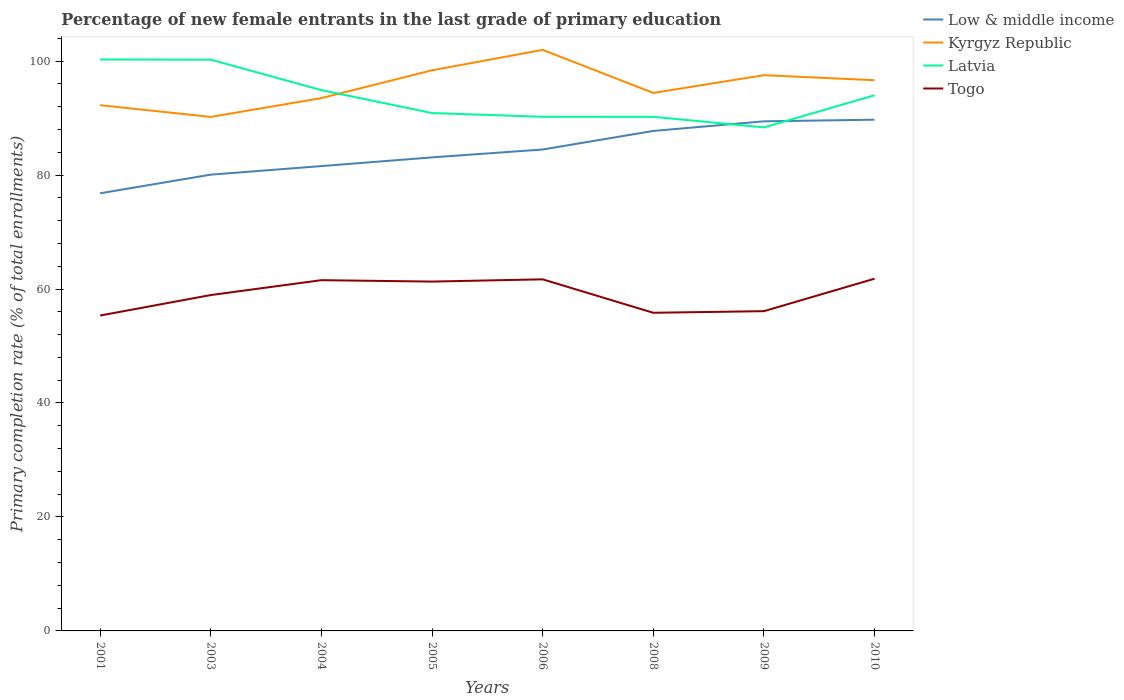Does the line corresponding to Kyrgyz Republic intersect with the line corresponding to Togo?
Keep it short and to the point. No. Across all years, what is the maximum percentage of new female entrants in Togo?
Your answer should be compact. 55.34. What is the total percentage of new female entrants in Togo in the graph?
Provide a short and direct response. -6.35. What is the difference between the highest and the second highest percentage of new female entrants in Togo?
Provide a short and direct response. 6.46. What is the difference between the highest and the lowest percentage of new female entrants in Kyrgyz Republic?
Give a very brief answer. 4. How many years are there in the graph?
Provide a short and direct response. 8. What is the difference between two consecutive major ticks on the Y-axis?
Provide a short and direct response. 20. Are the values on the major ticks of Y-axis written in scientific E-notation?
Ensure brevity in your answer.  No. Does the graph contain any zero values?
Provide a short and direct response. No. How are the legend labels stacked?
Make the answer very short. Vertical. What is the title of the graph?
Ensure brevity in your answer.  Percentage of new female entrants in the last grade of primary education. Does "Sudan" appear as one of the legend labels in the graph?
Your response must be concise. No. What is the label or title of the X-axis?
Provide a short and direct response. Years. What is the label or title of the Y-axis?
Ensure brevity in your answer.  Primary completion rate (% of total enrollments). What is the Primary completion rate (% of total enrollments) of Low & middle income in 2001?
Give a very brief answer. 76.79. What is the Primary completion rate (% of total enrollments) in Kyrgyz Republic in 2001?
Your answer should be very brief. 92.26. What is the Primary completion rate (% of total enrollments) of Latvia in 2001?
Give a very brief answer. 100.27. What is the Primary completion rate (% of total enrollments) of Togo in 2001?
Your answer should be very brief. 55.34. What is the Primary completion rate (% of total enrollments) of Low & middle income in 2003?
Keep it short and to the point. 80.07. What is the Primary completion rate (% of total enrollments) in Kyrgyz Republic in 2003?
Offer a terse response. 90.2. What is the Primary completion rate (% of total enrollments) of Latvia in 2003?
Make the answer very short. 100.25. What is the Primary completion rate (% of total enrollments) of Togo in 2003?
Make the answer very short. 58.94. What is the Primary completion rate (% of total enrollments) of Low & middle income in 2004?
Your answer should be very brief. 81.57. What is the Primary completion rate (% of total enrollments) of Kyrgyz Republic in 2004?
Give a very brief answer. 93.5. What is the Primary completion rate (% of total enrollments) of Latvia in 2004?
Offer a terse response. 94.9. What is the Primary completion rate (% of total enrollments) in Togo in 2004?
Your response must be concise. 61.55. What is the Primary completion rate (% of total enrollments) of Low & middle income in 2005?
Your response must be concise. 83.1. What is the Primary completion rate (% of total enrollments) in Kyrgyz Republic in 2005?
Your answer should be compact. 98.38. What is the Primary completion rate (% of total enrollments) of Latvia in 2005?
Provide a short and direct response. 90.88. What is the Primary completion rate (% of total enrollments) in Togo in 2005?
Offer a very short reply. 61.3. What is the Primary completion rate (% of total enrollments) in Low & middle income in 2006?
Your answer should be compact. 84.48. What is the Primary completion rate (% of total enrollments) in Kyrgyz Republic in 2006?
Make the answer very short. 101.97. What is the Primary completion rate (% of total enrollments) of Latvia in 2006?
Ensure brevity in your answer.  90.22. What is the Primary completion rate (% of total enrollments) of Togo in 2006?
Keep it short and to the point. 61.7. What is the Primary completion rate (% of total enrollments) of Low & middle income in 2008?
Keep it short and to the point. 87.74. What is the Primary completion rate (% of total enrollments) of Kyrgyz Republic in 2008?
Offer a terse response. 94.41. What is the Primary completion rate (% of total enrollments) of Latvia in 2008?
Your answer should be compact. 90.22. What is the Primary completion rate (% of total enrollments) of Togo in 2008?
Keep it short and to the point. 55.83. What is the Primary completion rate (% of total enrollments) in Low & middle income in 2009?
Your response must be concise. 89.42. What is the Primary completion rate (% of total enrollments) in Kyrgyz Republic in 2009?
Offer a very short reply. 97.52. What is the Primary completion rate (% of total enrollments) of Latvia in 2009?
Provide a succinct answer. 88.36. What is the Primary completion rate (% of total enrollments) of Togo in 2009?
Your response must be concise. 56.11. What is the Primary completion rate (% of total enrollments) in Low & middle income in 2010?
Your answer should be very brief. 89.71. What is the Primary completion rate (% of total enrollments) of Kyrgyz Republic in 2010?
Keep it short and to the point. 96.64. What is the Primary completion rate (% of total enrollments) of Latvia in 2010?
Offer a terse response. 94. What is the Primary completion rate (% of total enrollments) in Togo in 2010?
Your answer should be compact. 61.81. Across all years, what is the maximum Primary completion rate (% of total enrollments) of Low & middle income?
Offer a very short reply. 89.71. Across all years, what is the maximum Primary completion rate (% of total enrollments) of Kyrgyz Republic?
Keep it short and to the point. 101.97. Across all years, what is the maximum Primary completion rate (% of total enrollments) of Latvia?
Keep it short and to the point. 100.27. Across all years, what is the maximum Primary completion rate (% of total enrollments) in Togo?
Your answer should be compact. 61.81. Across all years, what is the minimum Primary completion rate (% of total enrollments) of Low & middle income?
Give a very brief answer. 76.79. Across all years, what is the minimum Primary completion rate (% of total enrollments) of Kyrgyz Republic?
Offer a very short reply. 90.2. Across all years, what is the minimum Primary completion rate (% of total enrollments) in Latvia?
Make the answer very short. 88.36. Across all years, what is the minimum Primary completion rate (% of total enrollments) of Togo?
Ensure brevity in your answer.  55.34. What is the total Primary completion rate (% of total enrollments) of Low & middle income in the graph?
Offer a very short reply. 672.87. What is the total Primary completion rate (% of total enrollments) of Kyrgyz Republic in the graph?
Offer a very short reply. 764.87. What is the total Primary completion rate (% of total enrollments) in Latvia in the graph?
Your answer should be compact. 749.09. What is the total Primary completion rate (% of total enrollments) in Togo in the graph?
Make the answer very short. 472.58. What is the difference between the Primary completion rate (% of total enrollments) in Low & middle income in 2001 and that in 2003?
Make the answer very short. -3.27. What is the difference between the Primary completion rate (% of total enrollments) in Kyrgyz Republic in 2001 and that in 2003?
Provide a short and direct response. 2.06. What is the difference between the Primary completion rate (% of total enrollments) in Latvia in 2001 and that in 2003?
Make the answer very short. 0.03. What is the difference between the Primary completion rate (% of total enrollments) in Togo in 2001 and that in 2003?
Make the answer very short. -3.59. What is the difference between the Primary completion rate (% of total enrollments) of Low & middle income in 2001 and that in 2004?
Keep it short and to the point. -4.77. What is the difference between the Primary completion rate (% of total enrollments) in Kyrgyz Republic in 2001 and that in 2004?
Provide a succinct answer. -1.24. What is the difference between the Primary completion rate (% of total enrollments) in Latvia in 2001 and that in 2004?
Make the answer very short. 5.37. What is the difference between the Primary completion rate (% of total enrollments) of Togo in 2001 and that in 2004?
Your response must be concise. -6.2. What is the difference between the Primary completion rate (% of total enrollments) of Low & middle income in 2001 and that in 2005?
Offer a terse response. -6.3. What is the difference between the Primary completion rate (% of total enrollments) of Kyrgyz Republic in 2001 and that in 2005?
Keep it short and to the point. -6.12. What is the difference between the Primary completion rate (% of total enrollments) in Latvia in 2001 and that in 2005?
Provide a short and direct response. 9.4. What is the difference between the Primary completion rate (% of total enrollments) of Togo in 2001 and that in 2005?
Your response must be concise. -5.96. What is the difference between the Primary completion rate (% of total enrollments) in Low & middle income in 2001 and that in 2006?
Provide a succinct answer. -7.69. What is the difference between the Primary completion rate (% of total enrollments) in Kyrgyz Republic in 2001 and that in 2006?
Provide a succinct answer. -9.7. What is the difference between the Primary completion rate (% of total enrollments) in Latvia in 2001 and that in 2006?
Keep it short and to the point. 10.05. What is the difference between the Primary completion rate (% of total enrollments) of Togo in 2001 and that in 2006?
Offer a very short reply. -6.35. What is the difference between the Primary completion rate (% of total enrollments) in Low & middle income in 2001 and that in 2008?
Provide a succinct answer. -10.94. What is the difference between the Primary completion rate (% of total enrollments) in Kyrgyz Republic in 2001 and that in 2008?
Provide a succinct answer. -2.15. What is the difference between the Primary completion rate (% of total enrollments) in Latvia in 2001 and that in 2008?
Your answer should be very brief. 10.06. What is the difference between the Primary completion rate (% of total enrollments) in Togo in 2001 and that in 2008?
Keep it short and to the point. -0.48. What is the difference between the Primary completion rate (% of total enrollments) in Low & middle income in 2001 and that in 2009?
Give a very brief answer. -12.63. What is the difference between the Primary completion rate (% of total enrollments) in Kyrgyz Republic in 2001 and that in 2009?
Your answer should be compact. -5.26. What is the difference between the Primary completion rate (% of total enrollments) of Latvia in 2001 and that in 2009?
Keep it short and to the point. 11.91. What is the difference between the Primary completion rate (% of total enrollments) of Togo in 2001 and that in 2009?
Give a very brief answer. -0.76. What is the difference between the Primary completion rate (% of total enrollments) of Low & middle income in 2001 and that in 2010?
Your response must be concise. -12.92. What is the difference between the Primary completion rate (% of total enrollments) of Kyrgyz Republic in 2001 and that in 2010?
Ensure brevity in your answer.  -4.38. What is the difference between the Primary completion rate (% of total enrollments) in Latvia in 2001 and that in 2010?
Your answer should be very brief. 6.27. What is the difference between the Primary completion rate (% of total enrollments) in Togo in 2001 and that in 2010?
Offer a very short reply. -6.46. What is the difference between the Primary completion rate (% of total enrollments) of Low & middle income in 2003 and that in 2004?
Offer a terse response. -1.5. What is the difference between the Primary completion rate (% of total enrollments) of Kyrgyz Republic in 2003 and that in 2004?
Ensure brevity in your answer.  -3.31. What is the difference between the Primary completion rate (% of total enrollments) of Latvia in 2003 and that in 2004?
Your answer should be very brief. 5.35. What is the difference between the Primary completion rate (% of total enrollments) in Togo in 2003 and that in 2004?
Offer a terse response. -2.61. What is the difference between the Primary completion rate (% of total enrollments) in Low & middle income in 2003 and that in 2005?
Ensure brevity in your answer.  -3.03. What is the difference between the Primary completion rate (% of total enrollments) of Kyrgyz Republic in 2003 and that in 2005?
Provide a succinct answer. -8.18. What is the difference between the Primary completion rate (% of total enrollments) of Latvia in 2003 and that in 2005?
Give a very brief answer. 9.37. What is the difference between the Primary completion rate (% of total enrollments) in Togo in 2003 and that in 2005?
Offer a very short reply. -2.36. What is the difference between the Primary completion rate (% of total enrollments) of Low & middle income in 2003 and that in 2006?
Ensure brevity in your answer.  -4.41. What is the difference between the Primary completion rate (% of total enrollments) in Kyrgyz Republic in 2003 and that in 2006?
Make the answer very short. -11.77. What is the difference between the Primary completion rate (% of total enrollments) of Latvia in 2003 and that in 2006?
Give a very brief answer. 10.02. What is the difference between the Primary completion rate (% of total enrollments) in Togo in 2003 and that in 2006?
Keep it short and to the point. -2.76. What is the difference between the Primary completion rate (% of total enrollments) of Low & middle income in 2003 and that in 2008?
Give a very brief answer. -7.67. What is the difference between the Primary completion rate (% of total enrollments) in Kyrgyz Republic in 2003 and that in 2008?
Offer a terse response. -4.21. What is the difference between the Primary completion rate (% of total enrollments) of Latvia in 2003 and that in 2008?
Ensure brevity in your answer.  10.03. What is the difference between the Primary completion rate (% of total enrollments) in Togo in 2003 and that in 2008?
Provide a short and direct response. 3.11. What is the difference between the Primary completion rate (% of total enrollments) of Low & middle income in 2003 and that in 2009?
Keep it short and to the point. -9.36. What is the difference between the Primary completion rate (% of total enrollments) in Kyrgyz Republic in 2003 and that in 2009?
Your response must be concise. -7.33. What is the difference between the Primary completion rate (% of total enrollments) in Latvia in 2003 and that in 2009?
Your response must be concise. 11.89. What is the difference between the Primary completion rate (% of total enrollments) in Togo in 2003 and that in 2009?
Provide a short and direct response. 2.83. What is the difference between the Primary completion rate (% of total enrollments) in Low & middle income in 2003 and that in 2010?
Your answer should be compact. -9.64. What is the difference between the Primary completion rate (% of total enrollments) in Kyrgyz Republic in 2003 and that in 2010?
Your answer should be very brief. -6.44. What is the difference between the Primary completion rate (% of total enrollments) in Latvia in 2003 and that in 2010?
Ensure brevity in your answer.  6.25. What is the difference between the Primary completion rate (% of total enrollments) of Togo in 2003 and that in 2010?
Ensure brevity in your answer.  -2.87. What is the difference between the Primary completion rate (% of total enrollments) in Low & middle income in 2004 and that in 2005?
Offer a terse response. -1.53. What is the difference between the Primary completion rate (% of total enrollments) in Kyrgyz Republic in 2004 and that in 2005?
Keep it short and to the point. -4.87. What is the difference between the Primary completion rate (% of total enrollments) of Latvia in 2004 and that in 2005?
Ensure brevity in your answer.  4.02. What is the difference between the Primary completion rate (% of total enrollments) in Togo in 2004 and that in 2005?
Offer a very short reply. 0.25. What is the difference between the Primary completion rate (% of total enrollments) of Low & middle income in 2004 and that in 2006?
Ensure brevity in your answer.  -2.91. What is the difference between the Primary completion rate (% of total enrollments) of Kyrgyz Republic in 2004 and that in 2006?
Give a very brief answer. -8.46. What is the difference between the Primary completion rate (% of total enrollments) of Latvia in 2004 and that in 2006?
Offer a terse response. 4.68. What is the difference between the Primary completion rate (% of total enrollments) in Togo in 2004 and that in 2006?
Make the answer very short. -0.15. What is the difference between the Primary completion rate (% of total enrollments) of Low & middle income in 2004 and that in 2008?
Your answer should be compact. -6.17. What is the difference between the Primary completion rate (% of total enrollments) in Kyrgyz Republic in 2004 and that in 2008?
Keep it short and to the point. -0.9. What is the difference between the Primary completion rate (% of total enrollments) in Latvia in 2004 and that in 2008?
Keep it short and to the point. 4.68. What is the difference between the Primary completion rate (% of total enrollments) of Togo in 2004 and that in 2008?
Your response must be concise. 5.72. What is the difference between the Primary completion rate (% of total enrollments) in Low & middle income in 2004 and that in 2009?
Provide a short and direct response. -7.86. What is the difference between the Primary completion rate (% of total enrollments) in Kyrgyz Republic in 2004 and that in 2009?
Give a very brief answer. -4.02. What is the difference between the Primary completion rate (% of total enrollments) in Latvia in 2004 and that in 2009?
Your answer should be very brief. 6.54. What is the difference between the Primary completion rate (% of total enrollments) in Togo in 2004 and that in 2009?
Provide a short and direct response. 5.44. What is the difference between the Primary completion rate (% of total enrollments) of Low & middle income in 2004 and that in 2010?
Ensure brevity in your answer.  -8.14. What is the difference between the Primary completion rate (% of total enrollments) in Kyrgyz Republic in 2004 and that in 2010?
Offer a very short reply. -3.13. What is the difference between the Primary completion rate (% of total enrollments) in Togo in 2004 and that in 2010?
Your response must be concise. -0.26. What is the difference between the Primary completion rate (% of total enrollments) in Low & middle income in 2005 and that in 2006?
Ensure brevity in your answer.  -1.38. What is the difference between the Primary completion rate (% of total enrollments) of Kyrgyz Republic in 2005 and that in 2006?
Give a very brief answer. -3.59. What is the difference between the Primary completion rate (% of total enrollments) in Latvia in 2005 and that in 2006?
Your response must be concise. 0.65. What is the difference between the Primary completion rate (% of total enrollments) of Togo in 2005 and that in 2006?
Your response must be concise. -0.39. What is the difference between the Primary completion rate (% of total enrollments) of Low & middle income in 2005 and that in 2008?
Your answer should be compact. -4.64. What is the difference between the Primary completion rate (% of total enrollments) in Kyrgyz Republic in 2005 and that in 2008?
Provide a short and direct response. 3.97. What is the difference between the Primary completion rate (% of total enrollments) of Latvia in 2005 and that in 2008?
Keep it short and to the point. 0.66. What is the difference between the Primary completion rate (% of total enrollments) in Togo in 2005 and that in 2008?
Keep it short and to the point. 5.47. What is the difference between the Primary completion rate (% of total enrollments) of Low & middle income in 2005 and that in 2009?
Offer a terse response. -6.33. What is the difference between the Primary completion rate (% of total enrollments) of Kyrgyz Republic in 2005 and that in 2009?
Your answer should be compact. 0.85. What is the difference between the Primary completion rate (% of total enrollments) of Latvia in 2005 and that in 2009?
Give a very brief answer. 2.52. What is the difference between the Primary completion rate (% of total enrollments) of Togo in 2005 and that in 2009?
Ensure brevity in your answer.  5.19. What is the difference between the Primary completion rate (% of total enrollments) in Low & middle income in 2005 and that in 2010?
Give a very brief answer. -6.61. What is the difference between the Primary completion rate (% of total enrollments) of Kyrgyz Republic in 2005 and that in 2010?
Your answer should be very brief. 1.74. What is the difference between the Primary completion rate (% of total enrollments) of Latvia in 2005 and that in 2010?
Offer a very short reply. -3.12. What is the difference between the Primary completion rate (% of total enrollments) of Togo in 2005 and that in 2010?
Offer a terse response. -0.51. What is the difference between the Primary completion rate (% of total enrollments) in Low & middle income in 2006 and that in 2008?
Keep it short and to the point. -3.26. What is the difference between the Primary completion rate (% of total enrollments) in Kyrgyz Republic in 2006 and that in 2008?
Give a very brief answer. 7.56. What is the difference between the Primary completion rate (% of total enrollments) of Latvia in 2006 and that in 2008?
Your answer should be compact. 0.01. What is the difference between the Primary completion rate (% of total enrollments) of Togo in 2006 and that in 2008?
Provide a succinct answer. 5.87. What is the difference between the Primary completion rate (% of total enrollments) in Low & middle income in 2006 and that in 2009?
Provide a succinct answer. -4.94. What is the difference between the Primary completion rate (% of total enrollments) of Kyrgyz Republic in 2006 and that in 2009?
Ensure brevity in your answer.  4.44. What is the difference between the Primary completion rate (% of total enrollments) in Latvia in 2006 and that in 2009?
Your answer should be very brief. 1.86. What is the difference between the Primary completion rate (% of total enrollments) in Togo in 2006 and that in 2009?
Offer a very short reply. 5.59. What is the difference between the Primary completion rate (% of total enrollments) of Low & middle income in 2006 and that in 2010?
Keep it short and to the point. -5.23. What is the difference between the Primary completion rate (% of total enrollments) of Kyrgyz Republic in 2006 and that in 2010?
Ensure brevity in your answer.  5.33. What is the difference between the Primary completion rate (% of total enrollments) in Latvia in 2006 and that in 2010?
Give a very brief answer. -3.78. What is the difference between the Primary completion rate (% of total enrollments) in Togo in 2006 and that in 2010?
Give a very brief answer. -0.11. What is the difference between the Primary completion rate (% of total enrollments) of Low & middle income in 2008 and that in 2009?
Provide a short and direct response. -1.69. What is the difference between the Primary completion rate (% of total enrollments) of Kyrgyz Republic in 2008 and that in 2009?
Give a very brief answer. -3.12. What is the difference between the Primary completion rate (% of total enrollments) of Latvia in 2008 and that in 2009?
Provide a short and direct response. 1.86. What is the difference between the Primary completion rate (% of total enrollments) of Togo in 2008 and that in 2009?
Ensure brevity in your answer.  -0.28. What is the difference between the Primary completion rate (% of total enrollments) in Low & middle income in 2008 and that in 2010?
Ensure brevity in your answer.  -1.97. What is the difference between the Primary completion rate (% of total enrollments) of Kyrgyz Republic in 2008 and that in 2010?
Give a very brief answer. -2.23. What is the difference between the Primary completion rate (% of total enrollments) of Latvia in 2008 and that in 2010?
Ensure brevity in your answer.  -3.78. What is the difference between the Primary completion rate (% of total enrollments) in Togo in 2008 and that in 2010?
Offer a very short reply. -5.98. What is the difference between the Primary completion rate (% of total enrollments) of Low & middle income in 2009 and that in 2010?
Provide a short and direct response. -0.29. What is the difference between the Primary completion rate (% of total enrollments) in Kyrgyz Republic in 2009 and that in 2010?
Make the answer very short. 0.89. What is the difference between the Primary completion rate (% of total enrollments) of Latvia in 2009 and that in 2010?
Give a very brief answer. -5.64. What is the difference between the Primary completion rate (% of total enrollments) of Togo in 2009 and that in 2010?
Your answer should be compact. -5.7. What is the difference between the Primary completion rate (% of total enrollments) in Low & middle income in 2001 and the Primary completion rate (% of total enrollments) in Kyrgyz Republic in 2003?
Offer a terse response. -13.4. What is the difference between the Primary completion rate (% of total enrollments) in Low & middle income in 2001 and the Primary completion rate (% of total enrollments) in Latvia in 2003?
Keep it short and to the point. -23.45. What is the difference between the Primary completion rate (% of total enrollments) of Low & middle income in 2001 and the Primary completion rate (% of total enrollments) of Togo in 2003?
Your answer should be compact. 17.85. What is the difference between the Primary completion rate (% of total enrollments) in Kyrgyz Republic in 2001 and the Primary completion rate (% of total enrollments) in Latvia in 2003?
Keep it short and to the point. -7.99. What is the difference between the Primary completion rate (% of total enrollments) in Kyrgyz Republic in 2001 and the Primary completion rate (% of total enrollments) in Togo in 2003?
Your response must be concise. 33.32. What is the difference between the Primary completion rate (% of total enrollments) in Latvia in 2001 and the Primary completion rate (% of total enrollments) in Togo in 2003?
Make the answer very short. 41.33. What is the difference between the Primary completion rate (% of total enrollments) in Low & middle income in 2001 and the Primary completion rate (% of total enrollments) in Kyrgyz Republic in 2004?
Ensure brevity in your answer.  -16.71. What is the difference between the Primary completion rate (% of total enrollments) in Low & middle income in 2001 and the Primary completion rate (% of total enrollments) in Latvia in 2004?
Offer a terse response. -18.11. What is the difference between the Primary completion rate (% of total enrollments) in Low & middle income in 2001 and the Primary completion rate (% of total enrollments) in Togo in 2004?
Your answer should be compact. 15.24. What is the difference between the Primary completion rate (% of total enrollments) of Kyrgyz Republic in 2001 and the Primary completion rate (% of total enrollments) of Latvia in 2004?
Ensure brevity in your answer.  -2.64. What is the difference between the Primary completion rate (% of total enrollments) in Kyrgyz Republic in 2001 and the Primary completion rate (% of total enrollments) in Togo in 2004?
Offer a very short reply. 30.71. What is the difference between the Primary completion rate (% of total enrollments) in Latvia in 2001 and the Primary completion rate (% of total enrollments) in Togo in 2004?
Offer a very short reply. 38.72. What is the difference between the Primary completion rate (% of total enrollments) in Low & middle income in 2001 and the Primary completion rate (% of total enrollments) in Kyrgyz Republic in 2005?
Provide a short and direct response. -21.58. What is the difference between the Primary completion rate (% of total enrollments) in Low & middle income in 2001 and the Primary completion rate (% of total enrollments) in Latvia in 2005?
Your answer should be very brief. -14.08. What is the difference between the Primary completion rate (% of total enrollments) in Low & middle income in 2001 and the Primary completion rate (% of total enrollments) in Togo in 2005?
Your answer should be very brief. 15.49. What is the difference between the Primary completion rate (% of total enrollments) of Kyrgyz Republic in 2001 and the Primary completion rate (% of total enrollments) of Latvia in 2005?
Ensure brevity in your answer.  1.38. What is the difference between the Primary completion rate (% of total enrollments) in Kyrgyz Republic in 2001 and the Primary completion rate (% of total enrollments) in Togo in 2005?
Keep it short and to the point. 30.96. What is the difference between the Primary completion rate (% of total enrollments) of Latvia in 2001 and the Primary completion rate (% of total enrollments) of Togo in 2005?
Give a very brief answer. 38.97. What is the difference between the Primary completion rate (% of total enrollments) of Low & middle income in 2001 and the Primary completion rate (% of total enrollments) of Kyrgyz Republic in 2006?
Provide a succinct answer. -25.17. What is the difference between the Primary completion rate (% of total enrollments) of Low & middle income in 2001 and the Primary completion rate (% of total enrollments) of Latvia in 2006?
Provide a succinct answer. -13.43. What is the difference between the Primary completion rate (% of total enrollments) in Low & middle income in 2001 and the Primary completion rate (% of total enrollments) in Togo in 2006?
Your answer should be very brief. 15.1. What is the difference between the Primary completion rate (% of total enrollments) of Kyrgyz Republic in 2001 and the Primary completion rate (% of total enrollments) of Latvia in 2006?
Your answer should be very brief. 2.04. What is the difference between the Primary completion rate (% of total enrollments) of Kyrgyz Republic in 2001 and the Primary completion rate (% of total enrollments) of Togo in 2006?
Your answer should be compact. 30.56. What is the difference between the Primary completion rate (% of total enrollments) in Latvia in 2001 and the Primary completion rate (% of total enrollments) in Togo in 2006?
Make the answer very short. 38.58. What is the difference between the Primary completion rate (% of total enrollments) in Low & middle income in 2001 and the Primary completion rate (% of total enrollments) in Kyrgyz Republic in 2008?
Offer a terse response. -17.61. What is the difference between the Primary completion rate (% of total enrollments) in Low & middle income in 2001 and the Primary completion rate (% of total enrollments) in Latvia in 2008?
Keep it short and to the point. -13.42. What is the difference between the Primary completion rate (% of total enrollments) in Low & middle income in 2001 and the Primary completion rate (% of total enrollments) in Togo in 2008?
Your answer should be very brief. 20.96. What is the difference between the Primary completion rate (% of total enrollments) of Kyrgyz Republic in 2001 and the Primary completion rate (% of total enrollments) of Latvia in 2008?
Keep it short and to the point. 2.04. What is the difference between the Primary completion rate (% of total enrollments) in Kyrgyz Republic in 2001 and the Primary completion rate (% of total enrollments) in Togo in 2008?
Offer a terse response. 36.43. What is the difference between the Primary completion rate (% of total enrollments) of Latvia in 2001 and the Primary completion rate (% of total enrollments) of Togo in 2008?
Offer a terse response. 44.44. What is the difference between the Primary completion rate (% of total enrollments) of Low & middle income in 2001 and the Primary completion rate (% of total enrollments) of Kyrgyz Republic in 2009?
Make the answer very short. -20.73. What is the difference between the Primary completion rate (% of total enrollments) of Low & middle income in 2001 and the Primary completion rate (% of total enrollments) of Latvia in 2009?
Offer a very short reply. -11.56. What is the difference between the Primary completion rate (% of total enrollments) of Low & middle income in 2001 and the Primary completion rate (% of total enrollments) of Togo in 2009?
Provide a short and direct response. 20.68. What is the difference between the Primary completion rate (% of total enrollments) in Kyrgyz Republic in 2001 and the Primary completion rate (% of total enrollments) in Latvia in 2009?
Provide a short and direct response. 3.9. What is the difference between the Primary completion rate (% of total enrollments) of Kyrgyz Republic in 2001 and the Primary completion rate (% of total enrollments) of Togo in 2009?
Provide a short and direct response. 36.15. What is the difference between the Primary completion rate (% of total enrollments) in Latvia in 2001 and the Primary completion rate (% of total enrollments) in Togo in 2009?
Provide a succinct answer. 44.16. What is the difference between the Primary completion rate (% of total enrollments) in Low & middle income in 2001 and the Primary completion rate (% of total enrollments) in Kyrgyz Republic in 2010?
Your answer should be compact. -19.84. What is the difference between the Primary completion rate (% of total enrollments) of Low & middle income in 2001 and the Primary completion rate (% of total enrollments) of Latvia in 2010?
Your answer should be very brief. -17.21. What is the difference between the Primary completion rate (% of total enrollments) in Low & middle income in 2001 and the Primary completion rate (% of total enrollments) in Togo in 2010?
Your answer should be very brief. 14.99. What is the difference between the Primary completion rate (% of total enrollments) of Kyrgyz Republic in 2001 and the Primary completion rate (% of total enrollments) of Latvia in 2010?
Keep it short and to the point. -1.74. What is the difference between the Primary completion rate (% of total enrollments) of Kyrgyz Republic in 2001 and the Primary completion rate (% of total enrollments) of Togo in 2010?
Provide a short and direct response. 30.45. What is the difference between the Primary completion rate (% of total enrollments) in Latvia in 2001 and the Primary completion rate (% of total enrollments) in Togo in 2010?
Ensure brevity in your answer.  38.47. What is the difference between the Primary completion rate (% of total enrollments) of Low & middle income in 2003 and the Primary completion rate (% of total enrollments) of Kyrgyz Republic in 2004?
Your answer should be very brief. -13.44. What is the difference between the Primary completion rate (% of total enrollments) of Low & middle income in 2003 and the Primary completion rate (% of total enrollments) of Latvia in 2004?
Provide a short and direct response. -14.83. What is the difference between the Primary completion rate (% of total enrollments) in Low & middle income in 2003 and the Primary completion rate (% of total enrollments) in Togo in 2004?
Offer a terse response. 18.52. What is the difference between the Primary completion rate (% of total enrollments) in Kyrgyz Republic in 2003 and the Primary completion rate (% of total enrollments) in Latvia in 2004?
Your answer should be very brief. -4.7. What is the difference between the Primary completion rate (% of total enrollments) in Kyrgyz Republic in 2003 and the Primary completion rate (% of total enrollments) in Togo in 2004?
Offer a very short reply. 28.65. What is the difference between the Primary completion rate (% of total enrollments) of Latvia in 2003 and the Primary completion rate (% of total enrollments) of Togo in 2004?
Ensure brevity in your answer.  38.7. What is the difference between the Primary completion rate (% of total enrollments) in Low & middle income in 2003 and the Primary completion rate (% of total enrollments) in Kyrgyz Republic in 2005?
Offer a very short reply. -18.31. What is the difference between the Primary completion rate (% of total enrollments) in Low & middle income in 2003 and the Primary completion rate (% of total enrollments) in Latvia in 2005?
Offer a terse response. -10.81. What is the difference between the Primary completion rate (% of total enrollments) of Low & middle income in 2003 and the Primary completion rate (% of total enrollments) of Togo in 2005?
Make the answer very short. 18.77. What is the difference between the Primary completion rate (% of total enrollments) in Kyrgyz Republic in 2003 and the Primary completion rate (% of total enrollments) in Latvia in 2005?
Provide a succinct answer. -0.68. What is the difference between the Primary completion rate (% of total enrollments) of Kyrgyz Republic in 2003 and the Primary completion rate (% of total enrollments) of Togo in 2005?
Your answer should be compact. 28.9. What is the difference between the Primary completion rate (% of total enrollments) in Latvia in 2003 and the Primary completion rate (% of total enrollments) in Togo in 2005?
Keep it short and to the point. 38.95. What is the difference between the Primary completion rate (% of total enrollments) in Low & middle income in 2003 and the Primary completion rate (% of total enrollments) in Kyrgyz Republic in 2006?
Provide a short and direct response. -21.9. What is the difference between the Primary completion rate (% of total enrollments) in Low & middle income in 2003 and the Primary completion rate (% of total enrollments) in Latvia in 2006?
Provide a short and direct response. -10.16. What is the difference between the Primary completion rate (% of total enrollments) in Low & middle income in 2003 and the Primary completion rate (% of total enrollments) in Togo in 2006?
Make the answer very short. 18.37. What is the difference between the Primary completion rate (% of total enrollments) of Kyrgyz Republic in 2003 and the Primary completion rate (% of total enrollments) of Latvia in 2006?
Your answer should be very brief. -0.03. What is the difference between the Primary completion rate (% of total enrollments) in Kyrgyz Republic in 2003 and the Primary completion rate (% of total enrollments) in Togo in 2006?
Offer a terse response. 28.5. What is the difference between the Primary completion rate (% of total enrollments) in Latvia in 2003 and the Primary completion rate (% of total enrollments) in Togo in 2006?
Your answer should be very brief. 38.55. What is the difference between the Primary completion rate (% of total enrollments) in Low & middle income in 2003 and the Primary completion rate (% of total enrollments) in Kyrgyz Republic in 2008?
Offer a very short reply. -14.34. What is the difference between the Primary completion rate (% of total enrollments) in Low & middle income in 2003 and the Primary completion rate (% of total enrollments) in Latvia in 2008?
Keep it short and to the point. -10.15. What is the difference between the Primary completion rate (% of total enrollments) of Low & middle income in 2003 and the Primary completion rate (% of total enrollments) of Togo in 2008?
Provide a short and direct response. 24.24. What is the difference between the Primary completion rate (% of total enrollments) of Kyrgyz Republic in 2003 and the Primary completion rate (% of total enrollments) of Latvia in 2008?
Provide a succinct answer. -0.02. What is the difference between the Primary completion rate (% of total enrollments) of Kyrgyz Republic in 2003 and the Primary completion rate (% of total enrollments) of Togo in 2008?
Make the answer very short. 34.37. What is the difference between the Primary completion rate (% of total enrollments) in Latvia in 2003 and the Primary completion rate (% of total enrollments) in Togo in 2008?
Provide a short and direct response. 44.42. What is the difference between the Primary completion rate (% of total enrollments) in Low & middle income in 2003 and the Primary completion rate (% of total enrollments) in Kyrgyz Republic in 2009?
Make the answer very short. -17.46. What is the difference between the Primary completion rate (% of total enrollments) in Low & middle income in 2003 and the Primary completion rate (% of total enrollments) in Latvia in 2009?
Provide a short and direct response. -8.29. What is the difference between the Primary completion rate (% of total enrollments) in Low & middle income in 2003 and the Primary completion rate (% of total enrollments) in Togo in 2009?
Offer a terse response. 23.96. What is the difference between the Primary completion rate (% of total enrollments) of Kyrgyz Republic in 2003 and the Primary completion rate (% of total enrollments) of Latvia in 2009?
Your response must be concise. 1.84. What is the difference between the Primary completion rate (% of total enrollments) of Kyrgyz Republic in 2003 and the Primary completion rate (% of total enrollments) of Togo in 2009?
Give a very brief answer. 34.09. What is the difference between the Primary completion rate (% of total enrollments) of Latvia in 2003 and the Primary completion rate (% of total enrollments) of Togo in 2009?
Your response must be concise. 44.14. What is the difference between the Primary completion rate (% of total enrollments) in Low & middle income in 2003 and the Primary completion rate (% of total enrollments) in Kyrgyz Republic in 2010?
Your answer should be very brief. -16.57. What is the difference between the Primary completion rate (% of total enrollments) of Low & middle income in 2003 and the Primary completion rate (% of total enrollments) of Latvia in 2010?
Provide a short and direct response. -13.93. What is the difference between the Primary completion rate (% of total enrollments) in Low & middle income in 2003 and the Primary completion rate (% of total enrollments) in Togo in 2010?
Your answer should be compact. 18.26. What is the difference between the Primary completion rate (% of total enrollments) of Kyrgyz Republic in 2003 and the Primary completion rate (% of total enrollments) of Latvia in 2010?
Your answer should be compact. -3.8. What is the difference between the Primary completion rate (% of total enrollments) in Kyrgyz Republic in 2003 and the Primary completion rate (% of total enrollments) in Togo in 2010?
Your answer should be very brief. 28.39. What is the difference between the Primary completion rate (% of total enrollments) of Latvia in 2003 and the Primary completion rate (% of total enrollments) of Togo in 2010?
Your response must be concise. 38.44. What is the difference between the Primary completion rate (% of total enrollments) of Low & middle income in 2004 and the Primary completion rate (% of total enrollments) of Kyrgyz Republic in 2005?
Your answer should be compact. -16.81. What is the difference between the Primary completion rate (% of total enrollments) of Low & middle income in 2004 and the Primary completion rate (% of total enrollments) of Latvia in 2005?
Offer a terse response. -9.31. What is the difference between the Primary completion rate (% of total enrollments) in Low & middle income in 2004 and the Primary completion rate (% of total enrollments) in Togo in 2005?
Your response must be concise. 20.27. What is the difference between the Primary completion rate (% of total enrollments) in Kyrgyz Republic in 2004 and the Primary completion rate (% of total enrollments) in Latvia in 2005?
Provide a succinct answer. 2.63. What is the difference between the Primary completion rate (% of total enrollments) in Kyrgyz Republic in 2004 and the Primary completion rate (% of total enrollments) in Togo in 2005?
Ensure brevity in your answer.  32.2. What is the difference between the Primary completion rate (% of total enrollments) in Latvia in 2004 and the Primary completion rate (% of total enrollments) in Togo in 2005?
Your response must be concise. 33.6. What is the difference between the Primary completion rate (% of total enrollments) of Low & middle income in 2004 and the Primary completion rate (% of total enrollments) of Kyrgyz Republic in 2006?
Offer a terse response. -20.4. What is the difference between the Primary completion rate (% of total enrollments) in Low & middle income in 2004 and the Primary completion rate (% of total enrollments) in Latvia in 2006?
Keep it short and to the point. -8.66. What is the difference between the Primary completion rate (% of total enrollments) of Low & middle income in 2004 and the Primary completion rate (% of total enrollments) of Togo in 2006?
Your answer should be compact. 19.87. What is the difference between the Primary completion rate (% of total enrollments) of Kyrgyz Republic in 2004 and the Primary completion rate (% of total enrollments) of Latvia in 2006?
Keep it short and to the point. 3.28. What is the difference between the Primary completion rate (% of total enrollments) of Kyrgyz Republic in 2004 and the Primary completion rate (% of total enrollments) of Togo in 2006?
Give a very brief answer. 31.81. What is the difference between the Primary completion rate (% of total enrollments) in Latvia in 2004 and the Primary completion rate (% of total enrollments) in Togo in 2006?
Provide a short and direct response. 33.2. What is the difference between the Primary completion rate (% of total enrollments) of Low & middle income in 2004 and the Primary completion rate (% of total enrollments) of Kyrgyz Republic in 2008?
Offer a very short reply. -12.84. What is the difference between the Primary completion rate (% of total enrollments) of Low & middle income in 2004 and the Primary completion rate (% of total enrollments) of Latvia in 2008?
Offer a very short reply. -8.65. What is the difference between the Primary completion rate (% of total enrollments) of Low & middle income in 2004 and the Primary completion rate (% of total enrollments) of Togo in 2008?
Ensure brevity in your answer.  25.74. What is the difference between the Primary completion rate (% of total enrollments) in Kyrgyz Republic in 2004 and the Primary completion rate (% of total enrollments) in Latvia in 2008?
Ensure brevity in your answer.  3.29. What is the difference between the Primary completion rate (% of total enrollments) of Kyrgyz Republic in 2004 and the Primary completion rate (% of total enrollments) of Togo in 2008?
Your answer should be very brief. 37.67. What is the difference between the Primary completion rate (% of total enrollments) in Latvia in 2004 and the Primary completion rate (% of total enrollments) in Togo in 2008?
Provide a short and direct response. 39.07. What is the difference between the Primary completion rate (% of total enrollments) in Low & middle income in 2004 and the Primary completion rate (% of total enrollments) in Kyrgyz Republic in 2009?
Offer a very short reply. -15.96. What is the difference between the Primary completion rate (% of total enrollments) in Low & middle income in 2004 and the Primary completion rate (% of total enrollments) in Latvia in 2009?
Provide a short and direct response. -6.79. What is the difference between the Primary completion rate (% of total enrollments) in Low & middle income in 2004 and the Primary completion rate (% of total enrollments) in Togo in 2009?
Your answer should be very brief. 25.46. What is the difference between the Primary completion rate (% of total enrollments) in Kyrgyz Republic in 2004 and the Primary completion rate (% of total enrollments) in Latvia in 2009?
Keep it short and to the point. 5.14. What is the difference between the Primary completion rate (% of total enrollments) in Kyrgyz Republic in 2004 and the Primary completion rate (% of total enrollments) in Togo in 2009?
Provide a succinct answer. 37.39. What is the difference between the Primary completion rate (% of total enrollments) of Latvia in 2004 and the Primary completion rate (% of total enrollments) of Togo in 2009?
Offer a very short reply. 38.79. What is the difference between the Primary completion rate (% of total enrollments) of Low & middle income in 2004 and the Primary completion rate (% of total enrollments) of Kyrgyz Republic in 2010?
Ensure brevity in your answer.  -15.07. What is the difference between the Primary completion rate (% of total enrollments) in Low & middle income in 2004 and the Primary completion rate (% of total enrollments) in Latvia in 2010?
Ensure brevity in your answer.  -12.43. What is the difference between the Primary completion rate (% of total enrollments) in Low & middle income in 2004 and the Primary completion rate (% of total enrollments) in Togo in 2010?
Make the answer very short. 19.76. What is the difference between the Primary completion rate (% of total enrollments) of Kyrgyz Republic in 2004 and the Primary completion rate (% of total enrollments) of Latvia in 2010?
Your response must be concise. -0.5. What is the difference between the Primary completion rate (% of total enrollments) of Kyrgyz Republic in 2004 and the Primary completion rate (% of total enrollments) of Togo in 2010?
Ensure brevity in your answer.  31.7. What is the difference between the Primary completion rate (% of total enrollments) in Latvia in 2004 and the Primary completion rate (% of total enrollments) in Togo in 2010?
Provide a succinct answer. 33.09. What is the difference between the Primary completion rate (% of total enrollments) of Low & middle income in 2005 and the Primary completion rate (% of total enrollments) of Kyrgyz Republic in 2006?
Your answer should be compact. -18.87. What is the difference between the Primary completion rate (% of total enrollments) of Low & middle income in 2005 and the Primary completion rate (% of total enrollments) of Latvia in 2006?
Your answer should be very brief. -7.12. What is the difference between the Primary completion rate (% of total enrollments) in Low & middle income in 2005 and the Primary completion rate (% of total enrollments) in Togo in 2006?
Your answer should be compact. 21.4. What is the difference between the Primary completion rate (% of total enrollments) in Kyrgyz Republic in 2005 and the Primary completion rate (% of total enrollments) in Latvia in 2006?
Provide a succinct answer. 8.15. What is the difference between the Primary completion rate (% of total enrollments) of Kyrgyz Republic in 2005 and the Primary completion rate (% of total enrollments) of Togo in 2006?
Provide a succinct answer. 36.68. What is the difference between the Primary completion rate (% of total enrollments) of Latvia in 2005 and the Primary completion rate (% of total enrollments) of Togo in 2006?
Give a very brief answer. 29.18. What is the difference between the Primary completion rate (% of total enrollments) in Low & middle income in 2005 and the Primary completion rate (% of total enrollments) in Kyrgyz Republic in 2008?
Provide a short and direct response. -11.31. What is the difference between the Primary completion rate (% of total enrollments) of Low & middle income in 2005 and the Primary completion rate (% of total enrollments) of Latvia in 2008?
Your answer should be very brief. -7.12. What is the difference between the Primary completion rate (% of total enrollments) of Low & middle income in 2005 and the Primary completion rate (% of total enrollments) of Togo in 2008?
Keep it short and to the point. 27.27. What is the difference between the Primary completion rate (% of total enrollments) of Kyrgyz Republic in 2005 and the Primary completion rate (% of total enrollments) of Latvia in 2008?
Make the answer very short. 8.16. What is the difference between the Primary completion rate (% of total enrollments) of Kyrgyz Republic in 2005 and the Primary completion rate (% of total enrollments) of Togo in 2008?
Provide a short and direct response. 42.55. What is the difference between the Primary completion rate (% of total enrollments) in Latvia in 2005 and the Primary completion rate (% of total enrollments) in Togo in 2008?
Give a very brief answer. 35.05. What is the difference between the Primary completion rate (% of total enrollments) in Low & middle income in 2005 and the Primary completion rate (% of total enrollments) in Kyrgyz Republic in 2009?
Give a very brief answer. -14.42. What is the difference between the Primary completion rate (% of total enrollments) in Low & middle income in 2005 and the Primary completion rate (% of total enrollments) in Latvia in 2009?
Make the answer very short. -5.26. What is the difference between the Primary completion rate (% of total enrollments) in Low & middle income in 2005 and the Primary completion rate (% of total enrollments) in Togo in 2009?
Your response must be concise. 26.99. What is the difference between the Primary completion rate (% of total enrollments) in Kyrgyz Republic in 2005 and the Primary completion rate (% of total enrollments) in Latvia in 2009?
Your response must be concise. 10.02. What is the difference between the Primary completion rate (% of total enrollments) in Kyrgyz Republic in 2005 and the Primary completion rate (% of total enrollments) in Togo in 2009?
Keep it short and to the point. 42.27. What is the difference between the Primary completion rate (% of total enrollments) of Latvia in 2005 and the Primary completion rate (% of total enrollments) of Togo in 2009?
Your answer should be compact. 34.77. What is the difference between the Primary completion rate (% of total enrollments) of Low & middle income in 2005 and the Primary completion rate (% of total enrollments) of Kyrgyz Republic in 2010?
Your answer should be very brief. -13.54. What is the difference between the Primary completion rate (% of total enrollments) in Low & middle income in 2005 and the Primary completion rate (% of total enrollments) in Latvia in 2010?
Provide a short and direct response. -10.9. What is the difference between the Primary completion rate (% of total enrollments) in Low & middle income in 2005 and the Primary completion rate (% of total enrollments) in Togo in 2010?
Ensure brevity in your answer.  21.29. What is the difference between the Primary completion rate (% of total enrollments) in Kyrgyz Republic in 2005 and the Primary completion rate (% of total enrollments) in Latvia in 2010?
Your response must be concise. 4.38. What is the difference between the Primary completion rate (% of total enrollments) in Kyrgyz Republic in 2005 and the Primary completion rate (% of total enrollments) in Togo in 2010?
Offer a very short reply. 36.57. What is the difference between the Primary completion rate (% of total enrollments) in Latvia in 2005 and the Primary completion rate (% of total enrollments) in Togo in 2010?
Provide a succinct answer. 29.07. What is the difference between the Primary completion rate (% of total enrollments) of Low & middle income in 2006 and the Primary completion rate (% of total enrollments) of Kyrgyz Republic in 2008?
Offer a very short reply. -9.93. What is the difference between the Primary completion rate (% of total enrollments) in Low & middle income in 2006 and the Primary completion rate (% of total enrollments) in Latvia in 2008?
Ensure brevity in your answer.  -5.74. What is the difference between the Primary completion rate (% of total enrollments) in Low & middle income in 2006 and the Primary completion rate (% of total enrollments) in Togo in 2008?
Provide a short and direct response. 28.65. What is the difference between the Primary completion rate (% of total enrollments) in Kyrgyz Republic in 2006 and the Primary completion rate (% of total enrollments) in Latvia in 2008?
Give a very brief answer. 11.75. What is the difference between the Primary completion rate (% of total enrollments) of Kyrgyz Republic in 2006 and the Primary completion rate (% of total enrollments) of Togo in 2008?
Provide a short and direct response. 46.14. What is the difference between the Primary completion rate (% of total enrollments) of Latvia in 2006 and the Primary completion rate (% of total enrollments) of Togo in 2008?
Keep it short and to the point. 34.39. What is the difference between the Primary completion rate (% of total enrollments) of Low & middle income in 2006 and the Primary completion rate (% of total enrollments) of Kyrgyz Republic in 2009?
Provide a succinct answer. -13.04. What is the difference between the Primary completion rate (% of total enrollments) in Low & middle income in 2006 and the Primary completion rate (% of total enrollments) in Latvia in 2009?
Make the answer very short. -3.88. What is the difference between the Primary completion rate (% of total enrollments) in Low & middle income in 2006 and the Primary completion rate (% of total enrollments) in Togo in 2009?
Ensure brevity in your answer.  28.37. What is the difference between the Primary completion rate (% of total enrollments) of Kyrgyz Republic in 2006 and the Primary completion rate (% of total enrollments) of Latvia in 2009?
Offer a terse response. 13.61. What is the difference between the Primary completion rate (% of total enrollments) of Kyrgyz Republic in 2006 and the Primary completion rate (% of total enrollments) of Togo in 2009?
Offer a terse response. 45.86. What is the difference between the Primary completion rate (% of total enrollments) of Latvia in 2006 and the Primary completion rate (% of total enrollments) of Togo in 2009?
Your response must be concise. 34.11. What is the difference between the Primary completion rate (% of total enrollments) in Low & middle income in 2006 and the Primary completion rate (% of total enrollments) in Kyrgyz Republic in 2010?
Your answer should be compact. -12.16. What is the difference between the Primary completion rate (% of total enrollments) of Low & middle income in 2006 and the Primary completion rate (% of total enrollments) of Latvia in 2010?
Keep it short and to the point. -9.52. What is the difference between the Primary completion rate (% of total enrollments) of Low & middle income in 2006 and the Primary completion rate (% of total enrollments) of Togo in 2010?
Provide a succinct answer. 22.67. What is the difference between the Primary completion rate (% of total enrollments) of Kyrgyz Republic in 2006 and the Primary completion rate (% of total enrollments) of Latvia in 2010?
Offer a very short reply. 7.97. What is the difference between the Primary completion rate (% of total enrollments) of Kyrgyz Republic in 2006 and the Primary completion rate (% of total enrollments) of Togo in 2010?
Your answer should be compact. 40.16. What is the difference between the Primary completion rate (% of total enrollments) in Latvia in 2006 and the Primary completion rate (% of total enrollments) in Togo in 2010?
Provide a short and direct response. 28.42. What is the difference between the Primary completion rate (% of total enrollments) in Low & middle income in 2008 and the Primary completion rate (% of total enrollments) in Kyrgyz Republic in 2009?
Ensure brevity in your answer.  -9.79. What is the difference between the Primary completion rate (% of total enrollments) of Low & middle income in 2008 and the Primary completion rate (% of total enrollments) of Latvia in 2009?
Your answer should be compact. -0.62. What is the difference between the Primary completion rate (% of total enrollments) in Low & middle income in 2008 and the Primary completion rate (% of total enrollments) in Togo in 2009?
Your answer should be compact. 31.63. What is the difference between the Primary completion rate (% of total enrollments) in Kyrgyz Republic in 2008 and the Primary completion rate (% of total enrollments) in Latvia in 2009?
Give a very brief answer. 6.05. What is the difference between the Primary completion rate (% of total enrollments) in Kyrgyz Republic in 2008 and the Primary completion rate (% of total enrollments) in Togo in 2009?
Your response must be concise. 38.3. What is the difference between the Primary completion rate (% of total enrollments) in Latvia in 2008 and the Primary completion rate (% of total enrollments) in Togo in 2009?
Provide a short and direct response. 34.11. What is the difference between the Primary completion rate (% of total enrollments) in Low & middle income in 2008 and the Primary completion rate (% of total enrollments) in Kyrgyz Republic in 2010?
Make the answer very short. -8.9. What is the difference between the Primary completion rate (% of total enrollments) of Low & middle income in 2008 and the Primary completion rate (% of total enrollments) of Latvia in 2010?
Offer a very short reply. -6.26. What is the difference between the Primary completion rate (% of total enrollments) of Low & middle income in 2008 and the Primary completion rate (% of total enrollments) of Togo in 2010?
Your response must be concise. 25.93. What is the difference between the Primary completion rate (% of total enrollments) of Kyrgyz Republic in 2008 and the Primary completion rate (% of total enrollments) of Latvia in 2010?
Your response must be concise. 0.41. What is the difference between the Primary completion rate (% of total enrollments) in Kyrgyz Republic in 2008 and the Primary completion rate (% of total enrollments) in Togo in 2010?
Provide a short and direct response. 32.6. What is the difference between the Primary completion rate (% of total enrollments) in Latvia in 2008 and the Primary completion rate (% of total enrollments) in Togo in 2010?
Ensure brevity in your answer.  28.41. What is the difference between the Primary completion rate (% of total enrollments) of Low & middle income in 2009 and the Primary completion rate (% of total enrollments) of Kyrgyz Republic in 2010?
Give a very brief answer. -7.21. What is the difference between the Primary completion rate (% of total enrollments) of Low & middle income in 2009 and the Primary completion rate (% of total enrollments) of Latvia in 2010?
Make the answer very short. -4.57. What is the difference between the Primary completion rate (% of total enrollments) of Low & middle income in 2009 and the Primary completion rate (% of total enrollments) of Togo in 2010?
Your answer should be very brief. 27.62. What is the difference between the Primary completion rate (% of total enrollments) in Kyrgyz Republic in 2009 and the Primary completion rate (% of total enrollments) in Latvia in 2010?
Your answer should be compact. 3.52. What is the difference between the Primary completion rate (% of total enrollments) of Kyrgyz Republic in 2009 and the Primary completion rate (% of total enrollments) of Togo in 2010?
Your answer should be very brief. 35.72. What is the difference between the Primary completion rate (% of total enrollments) in Latvia in 2009 and the Primary completion rate (% of total enrollments) in Togo in 2010?
Provide a short and direct response. 26.55. What is the average Primary completion rate (% of total enrollments) in Low & middle income per year?
Offer a very short reply. 84.11. What is the average Primary completion rate (% of total enrollments) in Kyrgyz Republic per year?
Offer a terse response. 95.61. What is the average Primary completion rate (% of total enrollments) in Latvia per year?
Provide a succinct answer. 93.64. What is the average Primary completion rate (% of total enrollments) in Togo per year?
Provide a short and direct response. 59.07. In the year 2001, what is the difference between the Primary completion rate (% of total enrollments) of Low & middle income and Primary completion rate (% of total enrollments) of Kyrgyz Republic?
Your answer should be very brief. -15.47. In the year 2001, what is the difference between the Primary completion rate (% of total enrollments) of Low & middle income and Primary completion rate (% of total enrollments) of Latvia?
Provide a short and direct response. -23.48. In the year 2001, what is the difference between the Primary completion rate (% of total enrollments) of Low & middle income and Primary completion rate (% of total enrollments) of Togo?
Keep it short and to the point. 21.45. In the year 2001, what is the difference between the Primary completion rate (% of total enrollments) of Kyrgyz Republic and Primary completion rate (% of total enrollments) of Latvia?
Make the answer very short. -8.01. In the year 2001, what is the difference between the Primary completion rate (% of total enrollments) in Kyrgyz Republic and Primary completion rate (% of total enrollments) in Togo?
Your answer should be very brief. 36.92. In the year 2001, what is the difference between the Primary completion rate (% of total enrollments) of Latvia and Primary completion rate (% of total enrollments) of Togo?
Provide a short and direct response. 44.93. In the year 2003, what is the difference between the Primary completion rate (% of total enrollments) in Low & middle income and Primary completion rate (% of total enrollments) in Kyrgyz Republic?
Keep it short and to the point. -10.13. In the year 2003, what is the difference between the Primary completion rate (% of total enrollments) in Low & middle income and Primary completion rate (% of total enrollments) in Latvia?
Your response must be concise. -20.18. In the year 2003, what is the difference between the Primary completion rate (% of total enrollments) in Low & middle income and Primary completion rate (% of total enrollments) in Togo?
Provide a short and direct response. 21.13. In the year 2003, what is the difference between the Primary completion rate (% of total enrollments) of Kyrgyz Republic and Primary completion rate (% of total enrollments) of Latvia?
Your answer should be very brief. -10.05. In the year 2003, what is the difference between the Primary completion rate (% of total enrollments) in Kyrgyz Republic and Primary completion rate (% of total enrollments) in Togo?
Offer a very short reply. 31.26. In the year 2003, what is the difference between the Primary completion rate (% of total enrollments) of Latvia and Primary completion rate (% of total enrollments) of Togo?
Offer a very short reply. 41.31. In the year 2004, what is the difference between the Primary completion rate (% of total enrollments) in Low & middle income and Primary completion rate (% of total enrollments) in Kyrgyz Republic?
Your response must be concise. -11.94. In the year 2004, what is the difference between the Primary completion rate (% of total enrollments) in Low & middle income and Primary completion rate (% of total enrollments) in Latvia?
Offer a very short reply. -13.33. In the year 2004, what is the difference between the Primary completion rate (% of total enrollments) of Low & middle income and Primary completion rate (% of total enrollments) of Togo?
Provide a succinct answer. 20.02. In the year 2004, what is the difference between the Primary completion rate (% of total enrollments) in Kyrgyz Republic and Primary completion rate (% of total enrollments) in Latvia?
Offer a very short reply. -1.4. In the year 2004, what is the difference between the Primary completion rate (% of total enrollments) in Kyrgyz Republic and Primary completion rate (% of total enrollments) in Togo?
Make the answer very short. 31.95. In the year 2004, what is the difference between the Primary completion rate (% of total enrollments) of Latvia and Primary completion rate (% of total enrollments) of Togo?
Your answer should be compact. 33.35. In the year 2005, what is the difference between the Primary completion rate (% of total enrollments) in Low & middle income and Primary completion rate (% of total enrollments) in Kyrgyz Republic?
Offer a terse response. -15.28. In the year 2005, what is the difference between the Primary completion rate (% of total enrollments) of Low & middle income and Primary completion rate (% of total enrollments) of Latvia?
Provide a succinct answer. -7.78. In the year 2005, what is the difference between the Primary completion rate (% of total enrollments) in Low & middle income and Primary completion rate (% of total enrollments) in Togo?
Your answer should be compact. 21.8. In the year 2005, what is the difference between the Primary completion rate (% of total enrollments) in Kyrgyz Republic and Primary completion rate (% of total enrollments) in Latvia?
Your response must be concise. 7.5. In the year 2005, what is the difference between the Primary completion rate (% of total enrollments) in Kyrgyz Republic and Primary completion rate (% of total enrollments) in Togo?
Keep it short and to the point. 37.07. In the year 2005, what is the difference between the Primary completion rate (% of total enrollments) in Latvia and Primary completion rate (% of total enrollments) in Togo?
Offer a terse response. 29.57. In the year 2006, what is the difference between the Primary completion rate (% of total enrollments) of Low & middle income and Primary completion rate (% of total enrollments) of Kyrgyz Republic?
Provide a succinct answer. -17.48. In the year 2006, what is the difference between the Primary completion rate (% of total enrollments) in Low & middle income and Primary completion rate (% of total enrollments) in Latvia?
Make the answer very short. -5.74. In the year 2006, what is the difference between the Primary completion rate (% of total enrollments) of Low & middle income and Primary completion rate (% of total enrollments) of Togo?
Make the answer very short. 22.78. In the year 2006, what is the difference between the Primary completion rate (% of total enrollments) of Kyrgyz Republic and Primary completion rate (% of total enrollments) of Latvia?
Offer a terse response. 11.74. In the year 2006, what is the difference between the Primary completion rate (% of total enrollments) in Kyrgyz Republic and Primary completion rate (% of total enrollments) in Togo?
Ensure brevity in your answer.  40.27. In the year 2006, what is the difference between the Primary completion rate (% of total enrollments) of Latvia and Primary completion rate (% of total enrollments) of Togo?
Keep it short and to the point. 28.53. In the year 2008, what is the difference between the Primary completion rate (% of total enrollments) in Low & middle income and Primary completion rate (% of total enrollments) in Kyrgyz Republic?
Give a very brief answer. -6.67. In the year 2008, what is the difference between the Primary completion rate (% of total enrollments) of Low & middle income and Primary completion rate (% of total enrollments) of Latvia?
Your answer should be compact. -2.48. In the year 2008, what is the difference between the Primary completion rate (% of total enrollments) of Low & middle income and Primary completion rate (% of total enrollments) of Togo?
Provide a succinct answer. 31.91. In the year 2008, what is the difference between the Primary completion rate (% of total enrollments) in Kyrgyz Republic and Primary completion rate (% of total enrollments) in Latvia?
Give a very brief answer. 4.19. In the year 2008, what is the difference between the Primary completion rate (% of total enrollments) of Kyrgyz Republic and Primary completion rate (% of total enrollments) of Togo?
Provide a succinct answer. 38.58. In the year 2008, what is the difference between the Primary completion rate (% of total enrollments) of Latvia and Primary completion rate (% of total enrollments) of Togo?
Give a very brief answer. 34.39. In the year 2009, what is the difference between the Primary completion rate (% of total enrollments) of Low & middle income and Primary completion rate (% of total enrollments) of Kyrgyz Republic?
Provide a short and direct response. -8.1. In the year 2009, what is the difference between the Primary completion rate (% of total enrollments) in Low & middle income and Primary completion rate (% of total enrollments) in Latvia?
Offer a very short reply. 1.07. In the year 2009, what is the difference between the Primary completion rate (% of total enrollments) in Low & middle income and Primary completion rate (% of total enrollments) in Togo?
Your response must be concise. 33.31. In the year 2009, what is the difference between the Primary completion rate (% of total enrollments) of Kyrgyz Republic and Primary completion rate (% of total enrollments) of Latvia?
Your response must be concise. 9.16. In the year 2009, what is the difference between the Primary completion rate (% of total enrollments) in Kyrgyz Republic and Primary completion rate (% of total enrollments) in Togo?
Your response must be concise. 41.41. In the year 2009, what is the difference between the Primary completion rate (% of total enrollments) in Latvia and Primary completion rate (% of total enrollments) in Togo?
Your answer should be compact. 32.25. In the year 2010, what is the difference between the Primary completion rate (% of total enrollments) in Low & middle income and Primary completion rate (% of total enrollments) in Kyrgyz Republic?
Ensure brevity in your answer.  -6.93. In the year 2010, what is the difference between the Primary completion rate (% of total enrollments) of Low & middle income and Primary completion rate (% of total enrollments) of Latvia?
Make the answer very short. -4.29. In the year 2010, what is the difference between the Primary completion rate (% of total enrollments) of Low & middle income and Primary completion rate (% of total enrollments) of Togo?
Offer a very short reply. 27.9. In the year 2010, what is the difference between the Primary completion rate (% of total enrollments) of Kyrgyz Republic and Primary completion rate (% of total enrollments) of Latvia?
Your response must be concise. 2.64. In the year 2010, what is the difference between the Primary completion rate (% of total enrollments) of Kyrgyz Republic and Primary completion rate (% of total enrollments) of Togo?
Ensure brevity in your answer.  34.83. In the year 2010, what is the difference between the Primary completion rate (% of total enrollments) in Latvia and Primary completion rate (% of total enrollments) in Togo?
Offer a terse response. 32.19. What is the ratio of the Primary completion rate (% of total enrollments) in Low & middle income in 2001 to that in 2003?
Your answer should be compact. 0.96. What is the ratio of the Primary completion rate (% of total enrollments) in Kyrgyz Republic in 2001 to that in 2003?
Keep it short and to the point. 1.02. What is the ratio of the Primary completion rate (% of total enrollments) of Togo in 2001 to that in 2003?
Your answer should be very brief. 0.94. What is the ratio of the Primary completion rate (% of total enrollments) in Low & middle income in 2001 to that in 2004?
Offer a terse response. 0.94. What is the ratio of the Primary completion rate (% of total enrollments) in Kyrgyz Republic in 2001 to that in 2004?
Provide a succinct answer. 0.99. What is the ratio of the Primary completion rate (% of total enrollments) of Latvia in 2001 to that in 2004?
Offer a terse response. 1.06. What is the ratio of the Primary completion rate (% of total enrollments) of Togo in 2001 to that in 2004?
Provide a short and direct response. 0.9. What is the ratio of the Primary completion rate (% of total enrollments) in Low & middle income in 2001 to that in 2005?
Make the answer very short. 0.92. What is the ratio of the Primary completion rate (% of total enrollments) of Kyrgyz Republic in 2001 to that in 2005?
Ensure brevity in your answer.  0.94. What is the ratio of the Primary completion rate (% of total enrollments) in Latvia in 2001 to that in 2005?
Provide a short and direct response. 1.1. What is the ratio of the Primary completion rate (% of total enrollments) in Togo in 2001 to that in 2005?
Offer a terse response. 0.9. What is the ratio of the Primary completion rate (% of total enrollments) of Low & middle income in 2001 to that in 2006?
Your answer should be compact. 0.91. What is the ratio of the Primary completion rate (% of total enrollments) of Kyrgyz Republic in 2001 to that in 2006?
Your answer should be very brief. 0.9. What is the ratio of the Primary completion rate (% of total enrollments) in Latvia in 2001 to that in 2006?
Your answer should be compact. 1.11. What is the ratio of the Primary completion rate (% of total enrollments) of Togo in 2001 to that in 2006?
Keep it short and to the point. 0.9. What is the ratio of the Primary completion rate (% of total enrollments) in Low & middle income in 2001 to that in 2008?
Make the answer very short. 0.88. What is the ratio of the Primary completion rate (% of total enrollments) in Kyrgyz Republic in 2001 to that in 2008?
Provide a short and direct response. 0.98. What is the ratio of the Primary completion rate (% of total enrollments) in Latvia in 2001 to that in 2008?
Provide a short and direct response. 1.11. What is the ratio of the Primary completion rate (% of total enrollments) of Togo in 2001 to that in 2008?
Provide a short and direct response. 0.99. What is the ratio of the Primary completion rate (% of total enrollments) of Low & middle income in 2001 to that in 2009?
Your answer should be compact. 0.86. What is the ratio of the Primary completion rate (% of total enrollments) in Kyrgyz Republic in 2001 to that in 2009?
Make the answer very short. 0.95. What is the ratio of the Primary completion rate (% of total enrollments) in Latvia in 2001 to that in 2009?
Ensure brevity in your answer.  1.13. What is the ratio of the Primary completion rate (% of total enrollments) of Togo in 2001 to that in 2009?
Your answer should be very brief. 0.99. What is the ratio of the Primary completion rate (% of total enrollments) of Low & middle income in 2001 to that in 2010?
Your response must be concise. 0.86. What is the ratio of the Primary completion rate (% of total enrollments) of Kyrgyz Republic in 2001 to that in 2010?
Your answer should be compact. 0.95. What is the ratio of the Primary completion rate (% of total enrollments) of Latvia in 2001 to that in 2010?
Offer a very short reply. 1.07. What is the ratio of the Primary completion rate (% of total enrollments) of Togo in 2001 to that in 2010?
Provide a succinct answer. 0.9. What is the ratio of the Primary completion rate (% of total enrollments) in Low & middle income in 2003 to that in 2004?
Your answer should be compact. 0.98. What is the ratio of the Primary completion rate (% of total enrollments) in Kyrgyz Republic in 2003 to that in 2004?
Keep it short and to the point. 0.96. What is the ratio of the Primary completion rate (% of total enrollments) in Latvia in 2003 to that in 2004?
Offer a very short reply. 1.06. What is the ratio of the Primary completion rate (% of total enrollments) of Togo in 2003 to that in 2004?
Ensure brevity in your answer.  0.96. What is the ratio of the Primary completion rate (% of total enrollments) of Low & middle income in 2003 to that in 2005?
Make the answer very short. 0.96. What is the ratio of the Primary completion rate (% of total enrollments) in Kyrgyz Republic in 2003 to that in 2005?
Offer a terse response. 0.92. What is the ratio of the Primary completion rate (% of total enrollments) of Latvia in 2003 to that in 2005?
Your answer should be very brief. 1.1. What is the ratio of the Primary completion rate (% of total enrollments) in Togo in 2003 to that in 2005?
Ensure brevity in your answer.  0.96. What is the ratio of the Primary completion rate (% of total enrollments) of Low & middle income in 2003 to that in 2006?
Provide a short and direct response. 0.95. What is the ratio of the Primary completion rate (% of total enrollments) of Kyrgyz Republic in 2003 to that in 2006?
Offer a terse response. 0.88. What is the ratio of the Primary completion rate (% of total enrollments) of Togo in 2003 to that in 2006?
Provide a short and direct response. 0.96. What is the ratio of the Primary completion rate (% of total enrollments) in Low & middle income in 2003 to that in 2008?
Ensure brevity in your answer.  0.91. What is the ratio of the Primary completion rate (% of total enrollments) in Kyrgyz Republic in 2003 to that in 2008?
Ensure brevity in your answer.  0.96. What is the ratio of the Primary completion rate (% of total enrollments) of Latvia in 2003 to that in 2008?
Keep it short and to the point. 1.11. What is the ratio of the Primary completion rate (% of total enrollments) in Togo in 2003 to that in 2008?
Your answer should be very brief. 1.06. What is the ratio of the Primary completion rate (% of total enrollments) in Low & middle income in 2003 to that in 2009?
Give a very brief answer. 0.9. What is the ratio of the Primary completion rate (% of total enrollments) in Kyrgyz Republic in 2003 to that in 2009?
Offer a terse response. 0.92. What is the ratio of the Primary completion rate (% of total enrollments) of Latvia in 2003 to that in 2009?
Provide a short and direct response. 1.13. What is the ratio of the Primary completion rate (% of total enrollments) in Togo in 2003 to that in 2009?
Make the answer very short. 1.05. What is the ratio of the Primary completion rate (% of total enrollments) in Low & middle income in 2003 to that in 2010?
Provide a succinct answer. 0.89. What is the ratio of the Primary completion rate (% of total enrollments) in Kyrgyz Republic in 2003 to that in 2010?
Make the answer very short. 0.93. What is the ratio of the Primary completion rate (% of total enrollments) in Latvia in 2003 to that in 2010?
Give a very brief answer. 1.07. What is the ratio of the Primary completion rate (% of total enrollments) of Togo in 2003 to that in 2010?
Your answer should be compact. 0.95. What is the ratio of the Primary completion rate (% of total enrollments) in Low & middle income in 2004 to that in 2005?
Your answer should be very brief. 0.98. What is the ratio of the Primary completion rate (% of total enrollments) of Kyrgyz Republic in 2004 to that in 2005?
Your answer should be very brief. 0.95. What is the ratio of the Primary completion rate (% of total enrollments) in Latvia in 2004 to that in 2005?
Provide a short and direct response. 1.04. What is the ratio of the Primary completion rate (% of total enrollments) of Low & middle income in 2004 to that in 2006?
Your answer should be compact. 0.97. What is the ratio of the Primary completion rate (% of total enrollments) of Kyrgyz Republic in 2004 to that in 2006?
Ensure brevity in your answer.  0.92. What is the ratio of the Primary completion rate (% of total enrollments) of Latvia in 2004 to that in 2006?
Make the answer very short. 1.05. What is the ratio of the Primary completion rate (% of total enrollments) of Togo in 2004 to that in 2006?
Offer a terse response. 1. What is the ratio of the Primary completion rate (% of total enrollments) of Low & middle income in 2004 to that in 2008?
Make the answer very short. 0.93. What is the ratio of the Primary completion rate (% of total enrollments) in Kyrgyz Republic in 2004 to that in 2008?
Give a very brief answer. 0.99. What is the ratio of the Primary completion rate (% of total enrollments) of Latvia in 2004 to that in 2008?
Your answer should be compact. 1.05. What is the ratio of the Primary completion rate (% of total enrollments) in Togo in 2004 to that in 2008?
Give a very brief answer. 1.1. What is the ratio of the Primary completion rate (% of total enrollments) in Low & middle income in 2004 to that in 2009?
Your answer should be compact. 0.91. What is the ratio of the Primary completion rate (% of total enrollments) of Kyrgyz Republic in 2004 to that in 2009?
Give a very brief answer. 0.96. What is the ratio of the Primary completion rate (% of total enrollments) in Latvia in 2004 to that in 2009?
Keep it short and to the point. 1.07. What is the ratio of the Primary completion rate (% of total enrollments) of Togo in 2004 to that in 2009?
Give a very brief answer. 1.1. What is the ratio of the Primary completion rate (% of total enrollments) of Low & middle income in 2004 to that in 2010?
Your response must be concise. 0.91. What is the ratio of the Primary completion rate (% of total enrollments) in Kyrgyz Republic in 2004 to that in 2010?
Your answer should be compact. 0.97. What is the ratio of the Primary completion rate (% of total enrollments) in Latvia in 2004 to that in 2010?
Your response must be concise. 1.01. What is the ratio of the Primary completion rate (% of total enrollments) in Togo in 2004 to that in 2010?
Make the answer very short. 1. What is the ratio of the Primary completion rate (% of total enrollments) in Low & middle income in 2005 to that in 2006?
Make the answer very short. 0.98. What is the ratio of the Primary completion rate (% of total enrollments) in Kyrgyz Republic in 2005 to that in 2006?
Your response must be concise. 0.96. What is the ratio of the Primary completion rate (% of total enrollments) in Togo in 2005 to that in 2006?
Provide a short and direct response. 0.99. What is the ratio of the Primary completion rate (% of total enrollments) in Low & middle income in 2005 to that in 2008?
Make the answer very short. 0.95. What is the ratio of the Primary completion rate (% of total enrollments) in Kyrgyz Republic in 2005 to that in 2008?
Offer a very short reply. 1.04. What is the ratio of the Primary completion rate (% of total enrollments) of Latvia in 2005 to that in 2008?
Your answer should be very brief. 1.01. What is the ratio of the Primary completion rate (% of total enrollments) of Togo in 2005 to that in 2008?
Provide a short and direct response. 1.1. What is the ratio of the Primary completion rate (% of total enrollments) of Low & middle income in 2005 to that in 2009?
Offer a very short reply. 0.93. What is the ratio of the Primary completion rate (% of total enrollments) of Kyrgyz Republic in 2005 to that in 2009?
Provide a succinct answer. 1.01. What is the ratio of the Primary completion rate (% of total enrollments) in Latvia in 2005 to that in 2009?
Your answer should be very brief. 1.03. What is the ratio of the Primary completion rate (% of total enrollments) in Togo in 2005 to that in 2009?
Your response must be concise. 1.09. What is the ratio of the Primary completion rate (% of total enrollments) of Low & middle income in 2005 to that in 2010?
Provide a short and direct response. 0.93. What is the ratio of the Primary completion rate (% of total enrollments) of Kyrgyz Republic in 2005 to that in 2010?
Make the answer very short. 1.02. What is the ratio of the Primary completion rate (% of total enrollments) of Latvia in 2005 to that in 2010?
Make the answer very short. 0.97. What is the ratio of the Primary completion rate (% of total enrollments) in Low & middle income in 2006 to that in 2008?
Ensure brevity in your answer.  0.96. What is the ratio of the Primary completion rate (% of total enrollments) in Kyrgyz Republic in 2006 to that in 2008?
Your response must be concise. 1.08. What is the ratio of the Primary completion rate (% of total enrollments) of Latvia in 2006 to that in 2008?
Your answer should be compact. 1. What is the ratio of the Primary completion rate (% of total enrollments) of Togo in 2006 to that in 2008?
Provide a short and direct response. 1.11. What is the ratio of the Primary completion rate (% of total enrollments) of Low & middle income in 2006 to that in 2009?
Your response must be concise. 0.94. What is the ratio of the Primary completion rate (% of total enrollments) in Kyrgyz Republic in 2006 to that in 2009?
Offer a terse response. 1.05. What is the ratio of the Primary completion rate (% of total enrollments) in Latvia in 2006 to that in 2009?
Make the answer very short. 1.02. What is the ratio of the Primary completion rate (% of total enrollments) in Togo in 2006 to that in 2009?
Make the answer very short. 1.1. What is the ratio of the Primary completion rate (% of total enrollments) in Low & middle income in 2006 to that in 2010?
Your answer should be compact. 0.94. What is the ratio of the Primary completion rate (% of total enrollments) in Kyrgyz Republic in 2006 to that in 2010?
Your answer should be very brief. 1.06. What is the ratio of the Primary completion rate (% of total enrollments) in Latvia in 2006 to that in 2010?
Provide a short and direct response. 0.96. What is the ratio of the Primary completion rate (% of total enrollments) in Low & middle income in 2008 to that in 2009?
Make the answer very short. 0.98. What is the ratio of the Primary completion rate (% of total enrollments) in Low & middle income in 2008 to that in 2010?
Your answer should be very brief. 0.98. What is the ratio of the Primary completion rate (% of total enrollments) in Kyrgyz Republic in 2008 to that in 2010?
Provide a short and direct response. 0.98. What is the ratio of the Primary completion rate (% of total enrollments) of Latvia in 2008 to that in 2010?
Ensure brevity in your answer.  0.96. What is the ratio of the Primary completion rate (% of total enrollments) of Togo in 2008 to that in 2010?
Your response must be concise. 0.9. What is the ratio of the Primary completion rate (% of total enrollments) of Kyrgyz Republic in 2009 to that in 2010?
Your response must be concise. 1.01. What is the ratio of the Primary completion rate (% of total enrollments) in Latvia in 2009 to that in 2010?
Your answer should be compact. 0.94. What is the ratio of the Primary completion rate (% of total enrollments) in Togo in 2009 to that in 2010?
Your answer should be compact. 0.91. What is the difference between the highest and the second highest Primary completion rate (% of total enrollments) in Low & middle income?
Your response must be concise. 0.29. What is the difference between the highest and the second highest Primary completion rate (% of total enrollments) in Kyrgyz Republic?
Ensure brevity in your answer.  3.59. What is the difference between the highest and the second highest Primary completion rate (% of total enrollments) of Latvia?
Give a very brief answer. 0.03. What is the difference between the highest and the second highest Primary completion rate (% of total enrollments) in Togo?
Provide a succinct answer. 0.11. What is the difference between the highest and the lowest Primary completion rate (% of total enrollments) in Low & middle income?
Ensure brevity in your answer.  12.92. What is the difference between the highest and the lowest Primary completion rate (% of total enrollments) of Kyrgyz Republic?
Your answer should be very brief. 11.77. What is the difference between the highest and the lowest Primary completion rate (% of total enrollments) in Latvia?
Make the answer very short. 11.91. What is the difference between the highest and the lowest Primary completion rate (% of total enrollments) of Togo?
Keep it short and to the point. 6.46. 